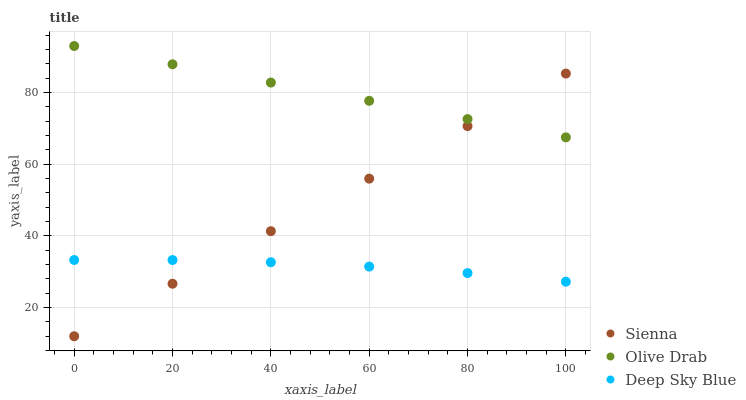Does Deep Sky Blue have the minimum area under the curve?
Answer yes or no. Yes. Does Olive Drab have the maximum area under the curve?
Answer yes or no. Yes. Does Olive Drab have the minimum area under the curve?
Answer yes or no. No. Does Deep Sky Blue have the maximum area under the curve?
Answer yes or no. No. Is Sienna the smoothest?
Answer yes or no. Yes. Is Deep Sky Blue the roughest?
Answer yes or no. Yes. Is Olive Drab the smoothest?
Answer yes or no. No. Is Olive Drab the roughest?
Answer yes or no. No. Does Sienna have the lowest value?
Answer yes or no. Yes. Does Deep Sky Blue have the lowest value?
Answer yes or no. No. Does Olive Drab have the highest value?
Answer yes or no. Yes. Does Deep Sky Blue have the highest value?
Answer yes or no. No. Is Deep Sky Blue less than Olive Drab?
Answer yes or no. Yes. Is Olive Drab greater than Deep Sky Blue?
Answer yes or no. Yes. Does Sienna intersect Olive Drab?
Answer yes or no. Yes. Is Sienna less than Olive Drab?
Answer yes or no. No. Is Sienna greater than Olive Drab?
Answer yes or no. No. Does Deep Sky Blue intersect Olive Drab?
Answer yes or no. No. 